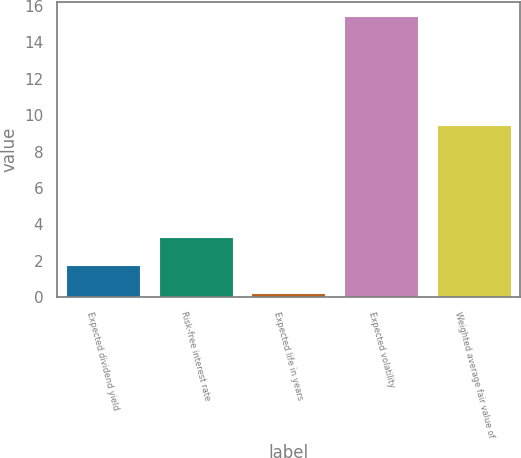Convert chart to OTSL. <chart><loc_0><loc_0><loc_500><loc_500><bar_chart><fcel>Expected dividend yield<fcel>Risk-free interest rate<fcel>Expected life in years<fcel>Expected volatility<fcel>Weighted average fair value of<nl><fcel>1.77<fcel>3.29<fcel>0.25<fcel>15.46<fcel>9.46<nl></chart> 